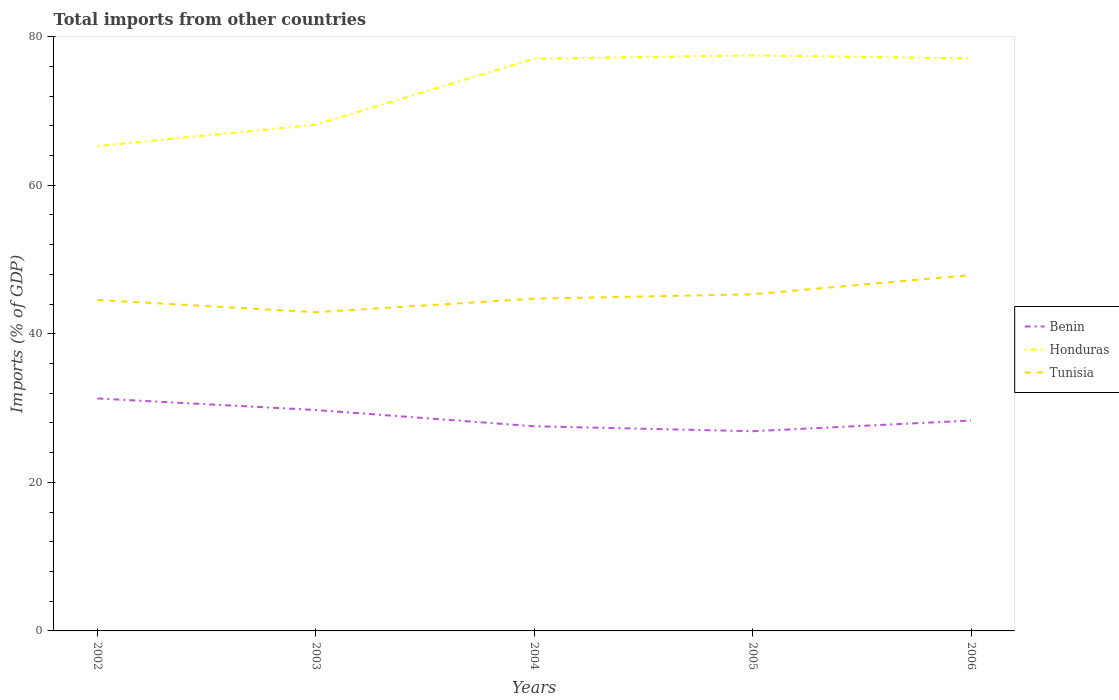Does the line corresponding to Honduras intersect with the line corresponding to Benin?
Your response must be concise. No. Is the number of lines equal to the number of legend labels?
Ensure brevity in your answer.  Yes. Across all years, what is the maximum total imports in Tunisia?
Your response must be concise. 42.91. What is the total total imports in Tunisia in the graph?
Make the answer very short. 1.65. What is the difference between the highest and the second highest total imports in Honduras?
Provide a succinct answer. 12.22. What is the difference between the highest and the lowest total imports in Benin?
Your answer should be very brief. 2. Does the graph contain grids?
Make the answer very short. No. How many legend labels are there?
Provide a short and direct response. 3. What is the title of the graph?
Keep it short and to the point. Total imports from other countries. What is the label or title of the X-axis?
Offer a very short reply. Years. What is the label or title of the Y-axis?
Your answer should be compact. Imports (% of GDP). What is the Imports (% of GDP) of Benin in 2002?
Offer a terse response. 31.3. What is the Imports (% of GDP) of Honduras in 2002?
Ensure brevity in your answer.  65.27. What is the Imports (% of GDP) of Tunisia in 2002?
Your response must be concise. 44.56. What is the Imports (% of GDP) of Benin in 2003?
Ensure brevity in your answer.  29.74. What is the Imports (% of GDP) in Honduras in 2003?
Provide a succinct answer. 68.15. What is the Imports (% of GDP) in Tunisia in 2003?
Ensure brevity in your answer.  42.91. What is the Imports (% of GDP) of Benin in 2004?
Make the answer very short. 27.55. What is the Imports (% of GDP) in Honduras in 2004?
Provide a short and direct response. 77.04. What is the Imports (% of GDP) in Tunisia in 2004?
Give a very brief answer. 44.73. What is the Imports (% of GDP) in Benin in 2005?
Make the answer very short. 26.88. What is the Imports (% of GDP) of Honduras in 2005?
Make the answer very short. 77.48. What is the Imports (% of GDP) of Tunisia in 2005?
Provide a short and direct response. 45.32. What is the Imports (% of GDP) of Benin in 2006?
Keep it short and to the point. 28.32. What is the Imports (% of GDP) in Honduras in 2006?
Make the answer very short. 77.08. What is the Imports (% of GDP) in Tunisia in 2006?
Your response must be concise. 47.91. Across all years, what is the maximum Imports (% of GDP) of Benin?
Your answer should be compact. 31.3. Across all years, what is the maximum Imports (% of GDP) of Honduras?
Provide a short and direct response. 77.48. Across all years, what is the maximum Imports (% of GDP) of Tunisia?
Your answer should be very brief. 47.91. Across all years, what is the minimum Imports (% of GDP) of Benin?
Provide a short and direct response. 26.88. Across all years, what is the minimum Imports (% of GDP) of Honduras?
Ensure brevity in your answer.  65.27. Across all years, what is the minimum Imports (% of GDP) in Tunisia?
Your response must be concise. 42.91. What is the total Imports (% of GDP) in Benin in the graph?
Make the answer very short. 143.79. What is the total Imports (% of GDP) of Honduras in the graph?
Keep it short and to the point. 365.02. What is the total Imports (% of GDP) of Tunisia in the graph?
Offer a very short reply. 225.42. What is the difference between the Imports (% of GDP) of Benin in 2002 and that in 2003?
Your answer should be very brief. 1.56. What is the difference between the Imports (% of GDP) in Honduras in 2002 and that in 2003?
Provide a succinct answer. -2.89. What is the difference between the Imports (% of GDP) in Tunisia in 2002 and that in 2003?
Keep it short and to the point. 1.65. What is the difference between the Imports (% of GDP) in Benin in 2002 and that in 2004?
Give a very brief answer. 3.74. What is the difference between the Imports (% of GDP) of Honduras in 2002 and that in 2004?
Offer a terse response. -11.77. What is the difference between the Imports (% of GDP) in Tunisia in 2002 and that in 2004?
Keep it short and to the point. -0.17. What is the difference between the Imports (% of GDP) in Benin in 2002 and that in 2005?
Offer a very short reply. 4.41. What is the difference between the Imports (% of GDP) of Honduras in 2002 and that in 2005?
Your answer should be compact. -12.22. What is the difference between the Imports (% of GDP) of Tunisia in 2002 and that in 2005?
Offer a very short reply. -0.76. What is the difference between the Imports (% of GDP) of Benin in 2002 and that in 2006?
Your answer should be compact. 2.97. What is the difference between the Imports (% of GDP) of Honduras in 2002 and that in 2006?
Your response must be concise. -11.81. What is the difference between the Imports (% of GDP) of Tunisia in 2002 and that in 2006?
Your answer should be compact. -3.35. What is the difference between the Imports (% of GDP) of Benin in 2003 and that in 2004?
Provide a short and direct response. 2.19. What is the difference between the Imports (% of GDP) of Honduras in 2003 and that in 2004?
Give a very brief answer. -8.88. What is the difference between the Imports (% of GDP) of Tunisia in 2003 and that in 2004?
Offer a terse response. -1.82. What is the difference between the Imports (% of GDP) in Benin in 2003 and that in 2005?
Give a very brief answer. 2.85. What is the difference between the Imports (% of GDP) of Honduras in 2003 and that in 2005?
Make the answer very short. -9.33. What is the difference between the Imports (% of GDP) of Tunisia in 2003 and that in 2005?
Ensure brevity in your answer.  -2.41. What is the difference between the Imports (% of GDP) in Benin in 2003 and that in 2006?
Provide a short and direct response. 1.41. What is the difference between the Imports (% of GDP) of Honduras in 2003 and that in 2006?
Give a very brief answer. -8.92. What is the difference between the Imports (% of GDP) in Tunisia in 2003 and that in 2006?
Offer a terse response. -5. What is the difference between the Imports (% of GDP) of Benin in 2004 and that in 2005?
Ensure brevity in your answer.  0.67. What is the difference between the Imports (% of GDP) of Honduras in 2004 and that in 2005?
Make the answer very short. -0.45. What is the difference between the Imports (% of GDP) of Tunisia in 2004 and that in 2005?
Give a very brief answer. -0.59. What is the difference between the Imports (% of GDP) of Benin in 2004 and that in 2006?
Give a very brief answer. -0.77. What is the difference between the Imports (% of GDP) of Honduras in 2004 and that in 2006?
Your answer should be compact. -0.04. What is the difference between the Imports (% of GDP) of Tunisia in 2004 and that in 2006?
Give a very brief answer. -3.18. What is the difference between the Imports (% of GDP) of Benin in 2005 and that in 2006?
Your answer should be very brief. -1.44. What is the difference between the Imports (% of GDP) of Honduras in 2005 and that in 2006?
Make the answer very short. 0.41. What is the difference between the Imports (% of GDP) in Tunisia in 2005 and that in 2006?
Keep it short and to the point. -2.59. What is the difference between the Imports (% of GDP) of Benin in 2002 and the Imports (% of GDP) of Honduras in 2003?
Ensure brevity in your answer.  -36.86. What is the difference between the Imports (% of GDP) in Benin in 2002 and the Imports (% of GDP) in Tunisia in 2003?
Your response must be concise. -11.61. What is the difference between the Imports (% of GDP) in Honduras in 2002 and the Imports (% of GDP) in Tunisia in 2003?
Provide a short and direct response. 22.36. What is the difference between the Imports (% of GDP) of Benin in 2002 and the Imports (% of GDP) of Honduras in 2004?
Offer a very short reply. -45.74. What is the difference between the Imports (% of GDP) in Benin in 2002 and the Imports (% of GDP) in Tunisia in 2004?
Your answer should be very brief. -13.43. What is the difference between the Imports (% of GDP) of Honduras in 2002 and the Imports (% of GDP) of Tunisia in 2004?
Offer a terse response. 20.54. What is the difference between the Imports (% of GDP) of Benin in 2002 and the Imports (% of GDP) of Honduras in 2005?
Give a very brief answer. -46.19. What is the difference between the Imports (% of GDP) of Benin in 2002 and the Imports (% of GDP) of Tunisia in 2005?
Give a very brief answer. -14.02. What is the difference between the Imports (% of GDP) in Honduras in 2002 and the Imports (% of GDP) in Tunisia in 2005?
Your answer should be very brief. 19.95. What is the difference between the Imports (% of GDP) in Benin in 2002 and the Imports (% of GDP) in Honduras in 2006?
Offer a terse response. -45.78. What is the difference between the Imports (% of GDP) in Benin in 2002 and the Imports (% of GDP) in Tunisia in 2006?
Provide a short and direct response. -16.61. What is the difference between the Imports (% of GDP) in Honduras in 2002 and the Imports (% of GDP) in Tunisia in 2006?
Your response must be concise. 17.36. What is the difference between the Imports (% of GDP) of Benin in 2003 and the Imports (% of GDP) of Honduras in 2004?
Offer a very short reply. -47.3. What is the difference between the Imports (% of GDP) in Benin in 2003 and the Imports (% of GDP) in Tunisia in 2004?
Your response must be concise. -14.99. What is the difference between the Imports (% of GDP) in Honduras in 2003 and the Imports (% of GDP) in Tunisia in 2004?
Your answer should be very brief. 23.43. What is the difference between the Imports (% of GDP) of Benin in 2003 and the Imports (% of GDP) of Honduras in 2005?
Keep it short and to the point. -47.75. What is the difference between the Imports (% of GDP) of Benin in 2003 and the Imports (% of GDP) of Tunisia in 2005?
Your response must be concise. -15.58. What is the difference between the Imports (% of GDP) of Honduras in 2003 and the Imports (% of GDP) of Tunisia in 2005?
Ensure brevity in your answer.  22.84. What is the difference between the Imports (% of GDP) in Benin in 2003 and the Imports (% of GDP) in Honduras in 2006?
Offer a terse response. -47.34. What is the difference between the Imports (% of GDP) in Benin in 2003 and the Imports (% of GDP) in Tunisia in 2006?
Make the answer very short. -18.17. What is the difference between the Imports (% of GDP) of Honduras in 2003 and the Imports (% of GDP) of Tunisia in 2006?
Your answer should be compact. 20.24. What is the difference between the Imports (% of GDP) in Benin in 2004 and the Imports (% of GDP) in Honduras in 2005?
Offer a terse response. -49.93. What is the difference between the Imports (% of GDP) of Benin in 2004 and the Imports (% of GDP) of Tunisia in 2005?
Provide a succinct answer. -17.77. What is the difference between the Imports (% of GDP) of Honduras in 2004 and the Imports (% of GDP) of Tunisia in 2005?
Keep it short and to the point. 31.72. What is the difference between the Imports (% of GDP) in Benin in 2004 and the Imports (% of GDP) in Honduras in 2006?
Provide a short and direct response. -49.53. What is the difference between the Imports (% of GDP) in Benin in 2004 and the Imports (% of GDP) in Tunisia in 2006?
Provide a succinct answer. -20.36. What is the difference between the Imports (% of GDP) of Honduras in 2004 and the Imports (% of GDP) of Tunisia in 2006?
Offer a very short reply. 29.13. What is the difference between the Imports (% of GDP) in Benin in 2005 and the Imports (% of GDP) in Honduras in 2006?
Ensure brevity in your answer.  -50.19. What is the difference between the Imports (% of GDP) of Benin in 2005 and the Imports (% of GDP) of Tunisia in 2006?
Offer a very short reply. -21.03. What is the difference between the Imports (% of GDP) of Honduras in 2005 and the Imports (% of GDP) of Tunisia in 2006?
Offer a very short reply. 29.57. What is the average Imports (% of GDP) in Benin per year?
Offer a terse response. 28.76. What is the average Imports (% of GDP) in Honduras per year?
Your answer should be compact. 73. What is the average Imports (% of GDP) in Tunisia per year?
Provide a short and direct response. 45.08. In the year 2002, what is the difference between the Imports (% of GDP) in Benin and Imports (% of GDP) in Honduras?
Make the answer very short. -33.97. In the year 2002, what is the difference between the Imports (% of GDP) of Benin and Imports (% of GDP) of Tunisia?
Keep it short and to the point. -13.26. In the year 2002, what is the difference between the Imports (% of GDP) in Honduras and Imports (% of GDP) in Tunisia?
Provide a short and direct response. 20.71. In the year 2003, what is the difference between the Imports (% of GDP) in Benin and Imports (% of GDP) in Honduras?
Offer a very short reply. -38.42. In the year 2003, what is the difference between the Imports (% of GDP) of Benin and Imports (% of GDP) of Tunisia?
Keep it short and to the point. -13.17. In the year 2003, what is the difference between the Imports (% of GDP) of Honduras and Imports (% of GDP) of Tunisia?
Your answer should be very brief. 25.25. In the year 2004, what is the difference between the Imports (% of GDP) in Benin and Imports (% of GDP) in Honduras?
Your answer should be compact. -49.49. In the year 2004, what is the difference between the Imports (% of GDP) of Benin and Imports (% of GDP) of Tunisia?
Your answer should be compact. -17.18. In the year 2004, what is the difference between the Imports (% of GDP) of Honduras and Imports (% of GDP) of Tunisia?
Offer a very short reply. 32.31. In the year 2005, what is the difference between the Imports (% of GDP) in Benin and Imports (% of GDP) in Honduras?
Provide a short and direct response. -50.6. In the year 2005, what is the difference between the Imports (% of GDP) of Benin and Imports (% of GDP) of Tunisia?
Your response must be concise. -18.43. In the year 2005, what is the difference between the Imports (% of GDP) of Honduras and Imports (% of GDP) of Tunisia?
Your response must be concise. 32.16. In the year 2006, what is the difference between the Imports (% of GDP) in Benin and Imports (% of GDP) in Honduras?
Your answer should be very brief. -48.75. In the year 2006, what is the difference between the Imports (% of GDP) of Benin and Imports (% of GDP) of Tunisia?
Keep it short and to the point. -19.59. In the year 2006, what is the difference between the Imports (% of GDP) in Honduras and Imports (% of GDP) in Tunisia?
Make the answer very short. 29.17. What is the ratio of the Imports (% of GDP) in Benin in 2002 to that in 2003?
Your answer should be very brief. 1.05. What is the ratio of the Imports (% of GDP) in Honduras in 2002 to that in 2003?
Make the answer very short. 0.96. What is the ratio of the Imports (% of GDP) in Benin in 2002 to that in 2004?
Make the answer very short. 1.14. What is the ratio of the Imports (% of GDP) of Honduras in 2002 to that in 2004?
Your answer should be compact. 0.85. What is the ratio of the Imports (% of GDP) in Tunisia in 2002 to that in 2004?
Make the answer very short. 1. What is the ratio of the Imports (% of GDP) of Benin in 2002 to that in 2005?
Your answer should be very brief. 1.16. What is the ratio of the Imports (% of GDP) in Honduras in 2002 to that in 2005?
Your answer should be very brief. 0.84. What is the ratio of the Imports (% of GDP) in Tunisia in 2002 to that in 2005?
Provide a short and direct response. 0.98. What is the ratio of the Imports (% of GDP) of Benin in 2002 to that in 2006?
Provide a succinct answer. 1.1. What is the ratio of the Imports (% of GDP) of Honduras in 2002 to that in 2006?
Give a very brief answer. 0.85. What is the ratio of the Imports (% of GDP) of Tunisia in 2002 to that in 2006?
Make the answer very short. 0.93. What is the ratio of the Imports (% of GDP) of Benin in 2003 to that in 2004?
Offer a very short reply. 1.08. What is the ratio of the Imports (% of GDP) in Honduras in 2003 to that in 2004?
Make the answer very short. 0.88. What is the ratio of the Imports (% of GDP) in Tunisia in 2003 to that in 2004?
Give a very brief answer. 0.96. What is the ratio of the Imports (% of GDP) in Benin in 2003 to that in 2005?
Your response must be concise. 1.11. What is the ratio of the Imports (% of GDP) of Honduras in 2003 to that in 2005?
Make the answer very short. 0.88. What is the ratio of the Imports (% of GDP) in Tunisia in 2003 to that in 2005?
Your response must be concise. 0.95. What is the ratio of the Imports (% of GDP) in Benin in 2003 to that in 2006?
Your response must be concise. 1.05. What is the ratio of the Imports (% of GDP) of Honduras in 2003 to that in 2006?
Make the answer very short. 0.88. What is the ratio of the Imports (% of GDP) of Tunisia in 2003 to that in 2006?
Give a very brief answer. 0.9. What is the ratio of the Imports (% of GDP) in Benin in 2004 to that in 2005?
Ensure brevity in your answer.  1.02. What is the ratio of the Imports (% of GDP) in Honduras in 2004 to that in 2005?
Offer a very short reply. 0.99. What is the ratio of the Imports (% of GDP) in Tunisia in 2004 to that in 2005?
Offer a very short reply. 0.99. What is the ratio of the Imports (% of GDP) in Benin in 2004 to that in 2006?
Provide a succinct answer. 0.97. What is the ratio of the Imports (% of GDP) in Honduras in 2004 to that in 2006?
Make the answer very short. 1. What is the ratio of the Imports (% of GDP) of Tunisia in 2004 to that in 2006?
Offer a terse response. 0.93. What is the ratio of the Imports (% of GDP) in Benin in 2005 to that in 2006?
Offer a very short reply. 0.95. What is the ratio of the Imports (% of GDP) of Tunisia in 2005 to that in 2006?
Offer a very short reply. 0.95. What is the difference between the highest and the second highest Imports (% of GDP) in Benin?
Ensure brevity in your answer.  1.56. What is the difference between the highest and the second highest Imports (% of GDP) in Honduras?
Provide a succinct answer. 0.41. What is the difference between the highest and the second highest Imports (% of GDP) in Tunisia?
Your response must be concise. 2.59. What is the difference between the highest and the lowest Imports (% of GDP) of Benin?
Keep it short and to the point. 4.41. What is the difference between the highest and the lowest Imports (% of GDP) in Honduras?
Your response must be concise. 12.22. What is the difference between the highest and the lowest Imports (% of GDP) in Tunisia?
Provide a short and direct response. 5. 